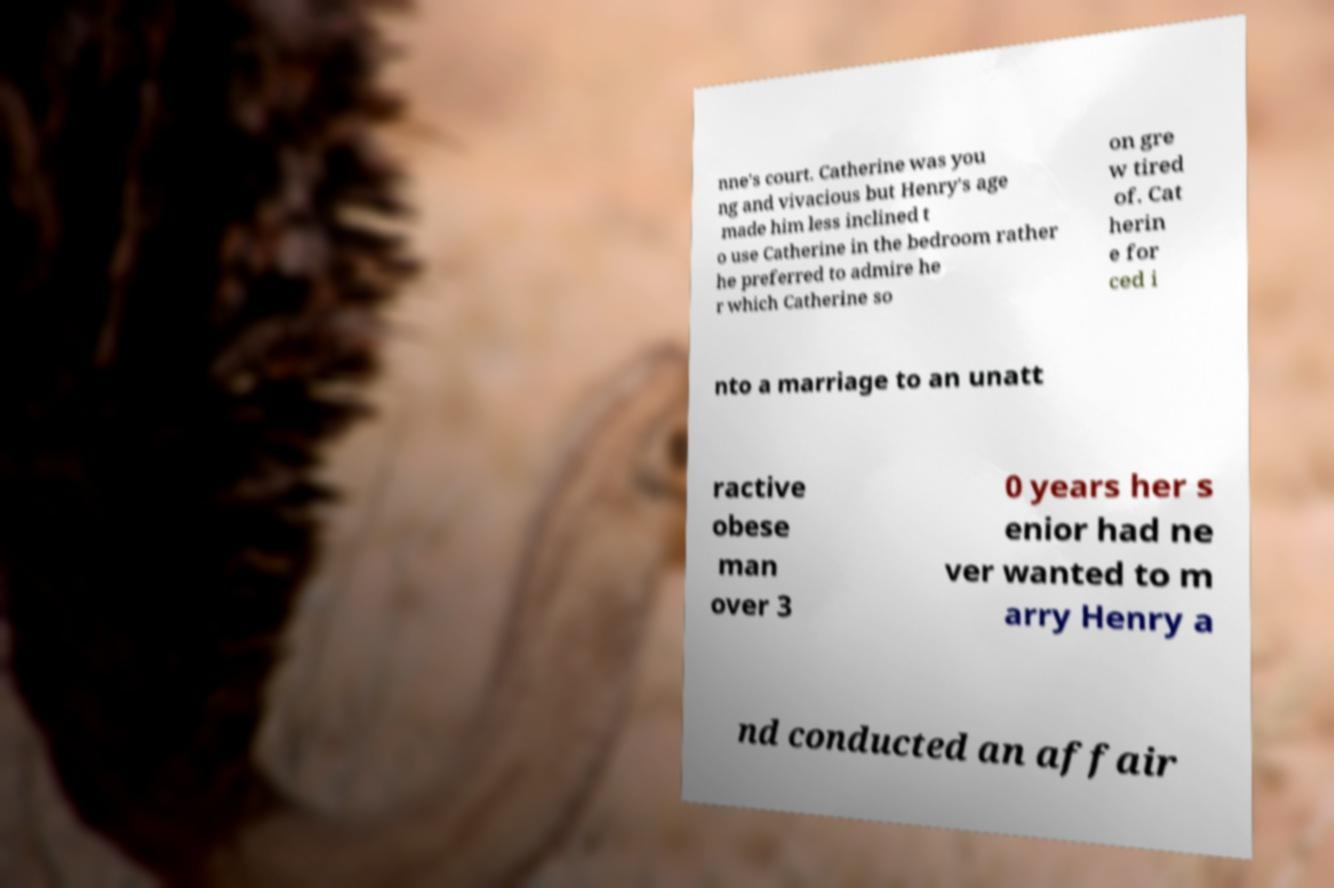Please read and relay the text visible in this image. What does it say? nne's court. Catherine was you ng and vivacious but Henry's age made him less inclined t o use Catherine in the bedroom rather he preferred to admire he r which Catherine so on gre w tired of. Cat herin e for ced i nto a marriage to an unatt ractive obese man over 3 0 years her s enior had ne ver wanted to m arry Henry a nd conducted an affair 